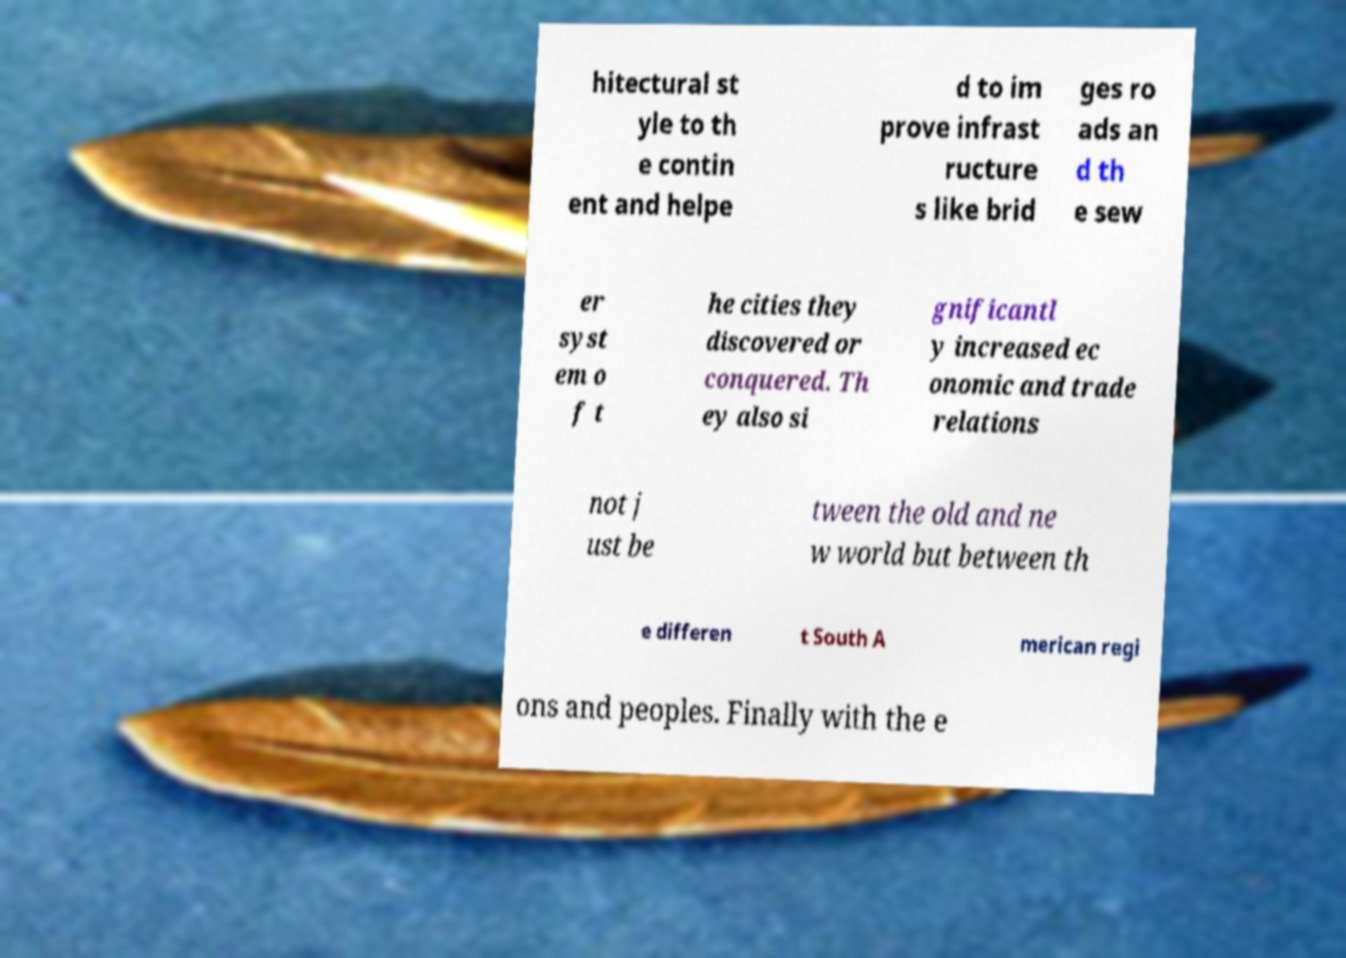Could you assist in decoding the text presented in this image and type it out clearly? hitectural st yle to th e contin ent and helpe d to im prove infrast ructure s like brid ges ro ads an d th e sew er syst em o f t he cities they discovered or conquered. Th ey also si gnificantl y increased ec onomic and trade relations not j ust be tween the old and ne w world but between th e differen t South A merican regi ons and peoples. Finally with the e 